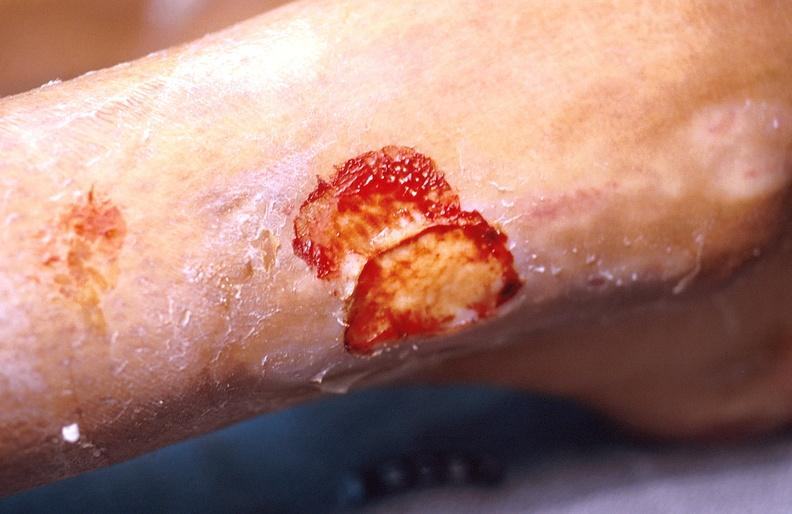where is this?
Answer the question using a single word or phrase. Skin 